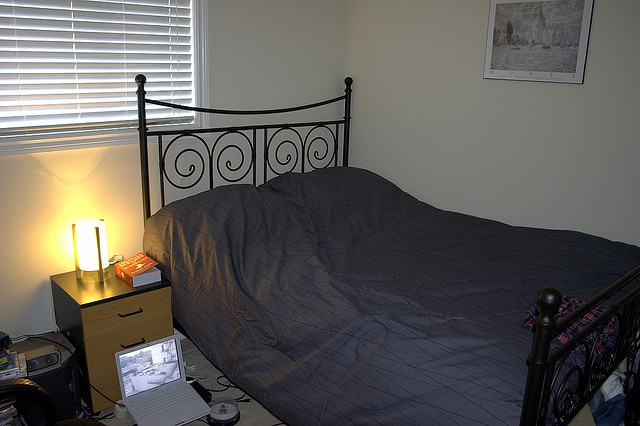Describe the objects in this image and their specific colors. I can see bed in gray and black tones, laptop in gray, lavender, and darkgray tones, book in gray, red, brown, and orange tones, and book in gray, black, navy, and darkgreen tones in this image. 